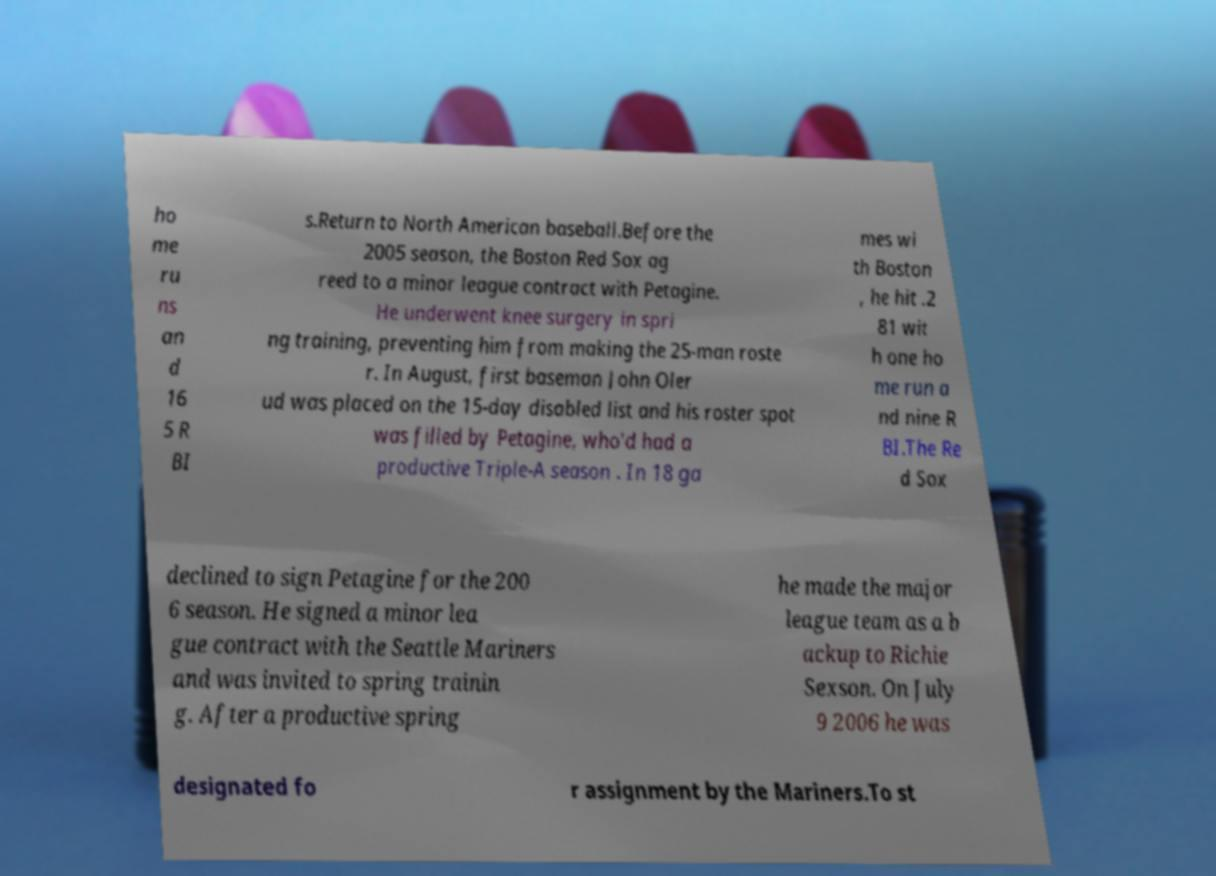For documentation purposes, I need the text within this image transcribed. Could you provide that? ho me ru ns an d 16 5 R BI s.Return to North American baseball.Before the 2005 season, the Boston Red Sox ag reed to a minor league contract with Petagine. He underwent knee surgery in spri ng training, preventing him from making the 25-man roste r. In August, first baseman John Oler ud was placed on the 15-day disabled list and his roster spot was filled by Petagine, who'd had a productive Triple-A season . In 18 ga mes wi th Boston , he hit .2 81 wit h one ho me run a nd nine R BI.The Re d Sox declined to sign Petagine for the 200 6 season. He signed a minor lea gue contract with the Seattle Mariners and was invited to spring trainin g. After a productive spring he made the major league team as a b ackup to Richie Sexson. On July 9 2006 he was designated fo r assignment by the Mariners.To st 